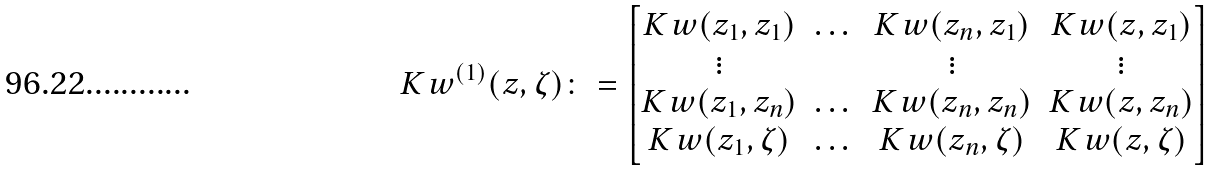<formula> <loc_0><loc_0><loc_500><loc_500>K _ { \ } w ^ { ( 1 ) } ( z , \zeta ) \colon = \begin{bmatrix} K _ { \ } w ( z _ { 1 } , z _ { 1 } ) & \dots & K _ { \ } w ( z _ { n } , z _ { 1 } ) & K _ { \ } w ( z , z _ { 1 } ) \\ \vdots & & \vdots & \vdots \\ K _ { \ } w ( z _ { 1 } , z _ { n } ) & \dots & K _ { \ } w ( z _ { n } , z _ { n } ) & K _ { \ } w ( z , z _ { n } ) \\ K _ { \ } w ( z _ { 1 } , \zeta ) & \dots & K _ { \ } w ( z _ { n } , \zeta ) & K _ { \ } w ( z , \zeta ) \end{bmatrix}</formula> 